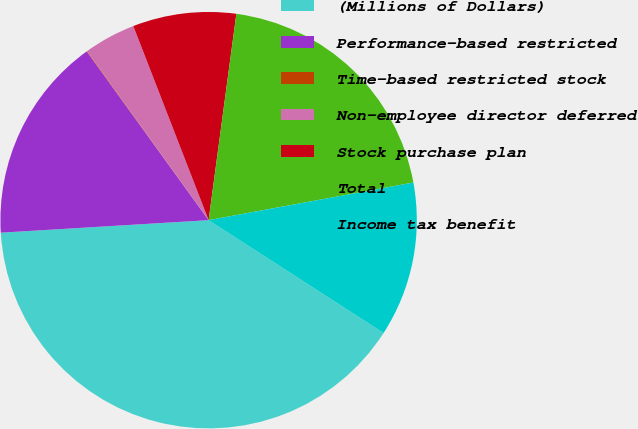<chart> <loc_0><loc_0><loc_500><loc_500><pie_chart><fcel>(Millions of Dollars)<fcel>Performance-based restricted<fcel>Time-based restricted stock<fcel>Non-employee director deferred<fcel>Stock purchase plan<fcel>Total<fcel>Income tax benefit<nl><fcel>39.93%<fcel>16.0%<fcel>0.04%<fcel>4.03%<fcel>8.02%<fcel>19.98%<fcel>12.01%<nl></chart> 